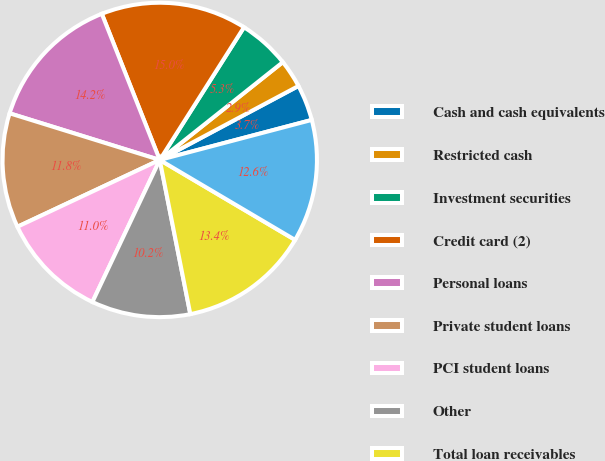Convert chart. <chart><loc_0><loc_0><loc_500><loc_500><pie_chart><fcel>Cash and cash equivalents<fcel>Restricted cash<fcel>Investment securities<fcel>Credit card (2)<fcel>Personal loans<fcel>Private student loans<fcel>PCI student loans<fcel>Other<fcel>Total loan receivables<fcel>Total interest-earning assets<nl><fcel>3.7%<fcel>2.89%<fcel>5.31%<fcel>15.01%<fcel>14.2%<fcel>11.78%<fcel>10.97%<fcel>10.16%<fcel>13.39%<fcel>12.59%<nl></chart> 